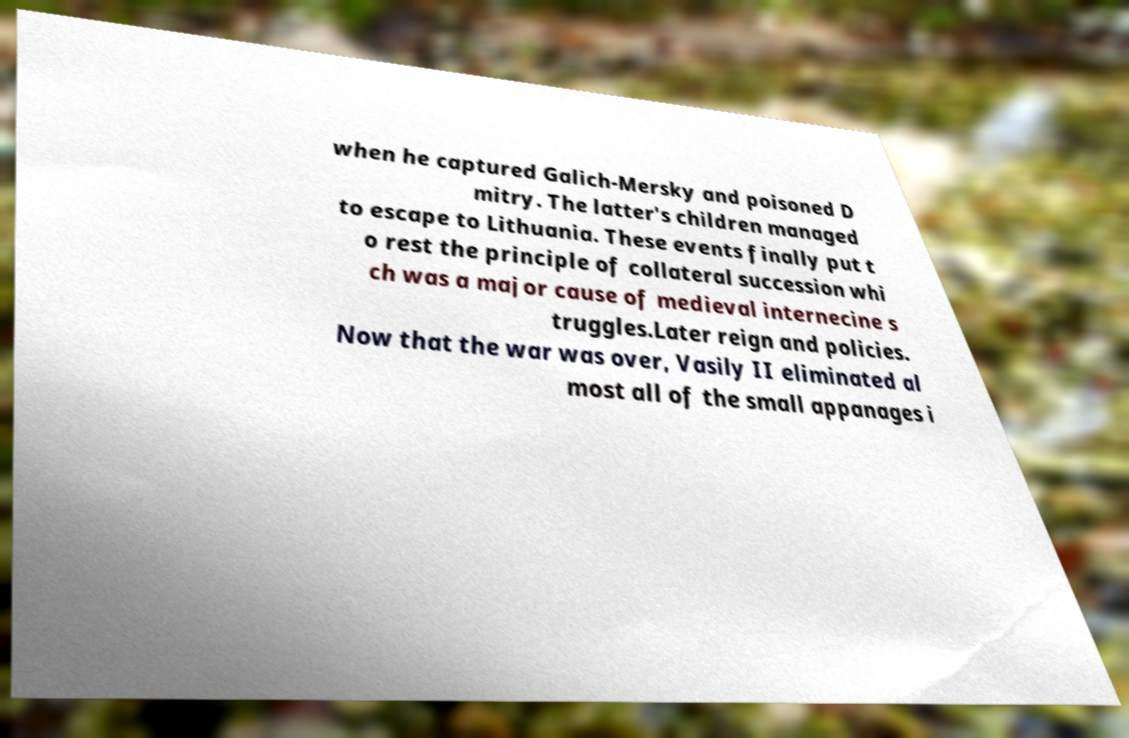Please identify and transcribe the text found in this image. when he captured Galich-Mersky and poisoned D mitry. The latter's children managed to escape to Lithuania. These events finally put t o rest the principle of collateral succession whi ch was a major cause of medieval internecine s truggles.Later reign and policies. Now that the war was over, Vasily II eliminated al most all of the small appanages i 